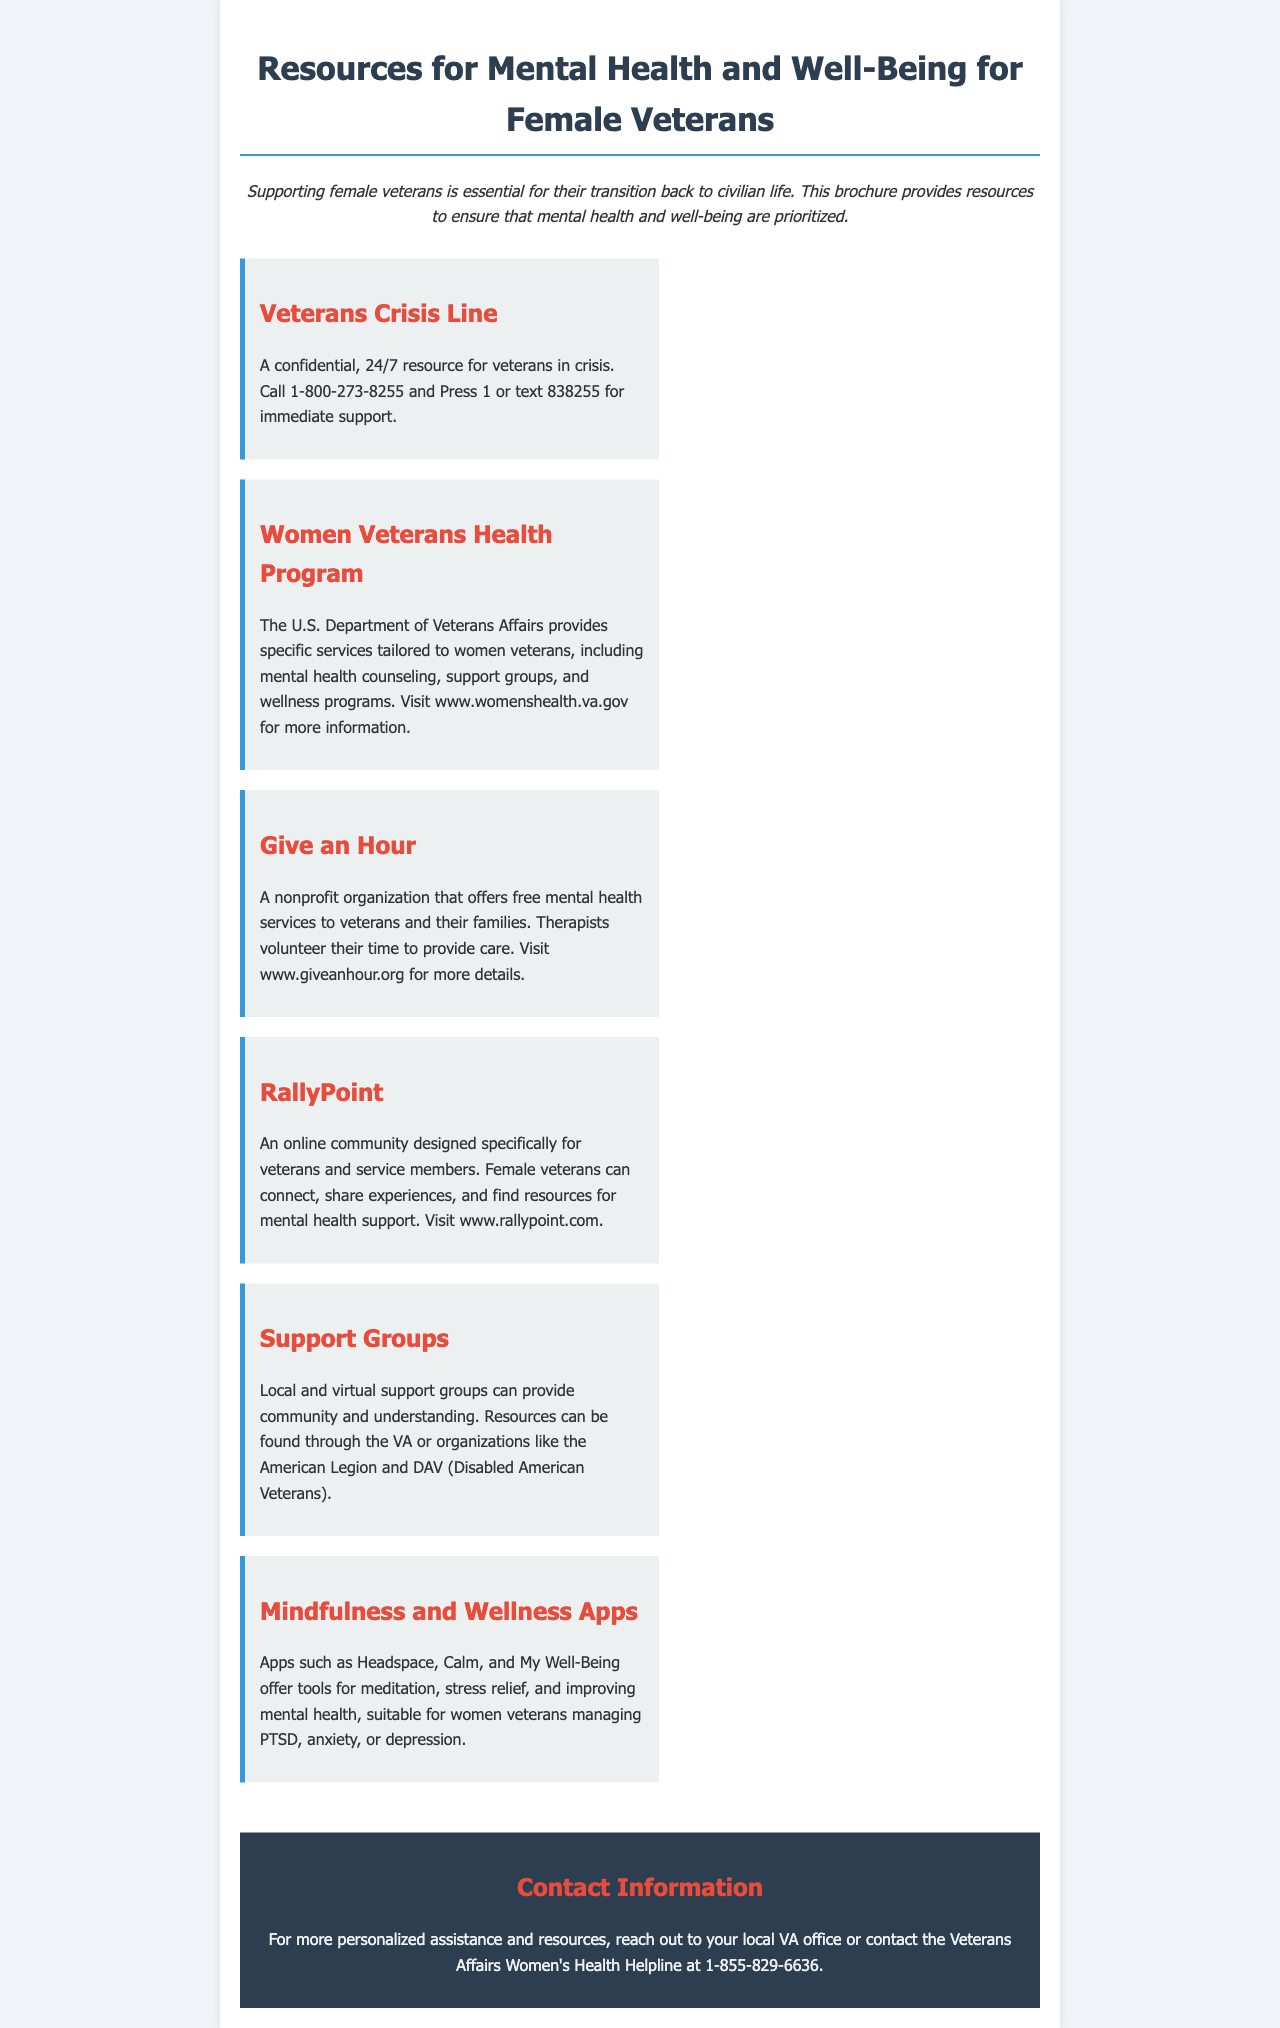What is the phone number for the Veterans Crisis Line? The Veterans Crisis Line's phone number is provided in the document, which is 1-800-273-8255.
Answer: 1-800-273-8255 What program provides specific services tailored to women veterans? The document mentions the Women Veterans Health Program, which is provided by the U.S. Department of Veterans Affairs.
Answer: Women Veterans Health Program What organization offers free mental health services to veterans and their families? The document refers to a nonprofit organization called Give an Hour that provides these services.
Answer: Give an Hour What online community connects female veterans for support? RallyPoint is mentioned in the document as an online community for veterans, specifically designed for this purpose.
Answer: RallyPoint What types of apps are recommended for mental health? The document lists mindfulness and wellness apps such as Headspace, Calm, and My Well-Being, which are recommended for mental health.
Answer: Headspace, Calm, My Well-Being How can someone reach the Veterans Affairs Women's Health Helpline? The helpline's contact number is provided in the contact information section of the document, which is 1-855-829-6636.
Answer: 1-855-829-6636 What is the main focus of the brochure? The brochure focuses on supporting female veterans during their transition back to civilian life and providing mental health resources.
Answer: Supporting female veterans What types of support groups are mentioned in the document? The document states that local and virtual support groups are available for veterans, which can provide community and understanding.
Answer: Local and virtual support groups What is the function of the Veterans Affairs local office? The local VA office is mentioned as a point of contact for personalized assistance and resources for veterans.
Answer: Personalized assistance and resources 